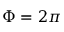<formula> <loc_0><loc_0><loc_500><loc_500>\Phi = 2 \pi</formula> 